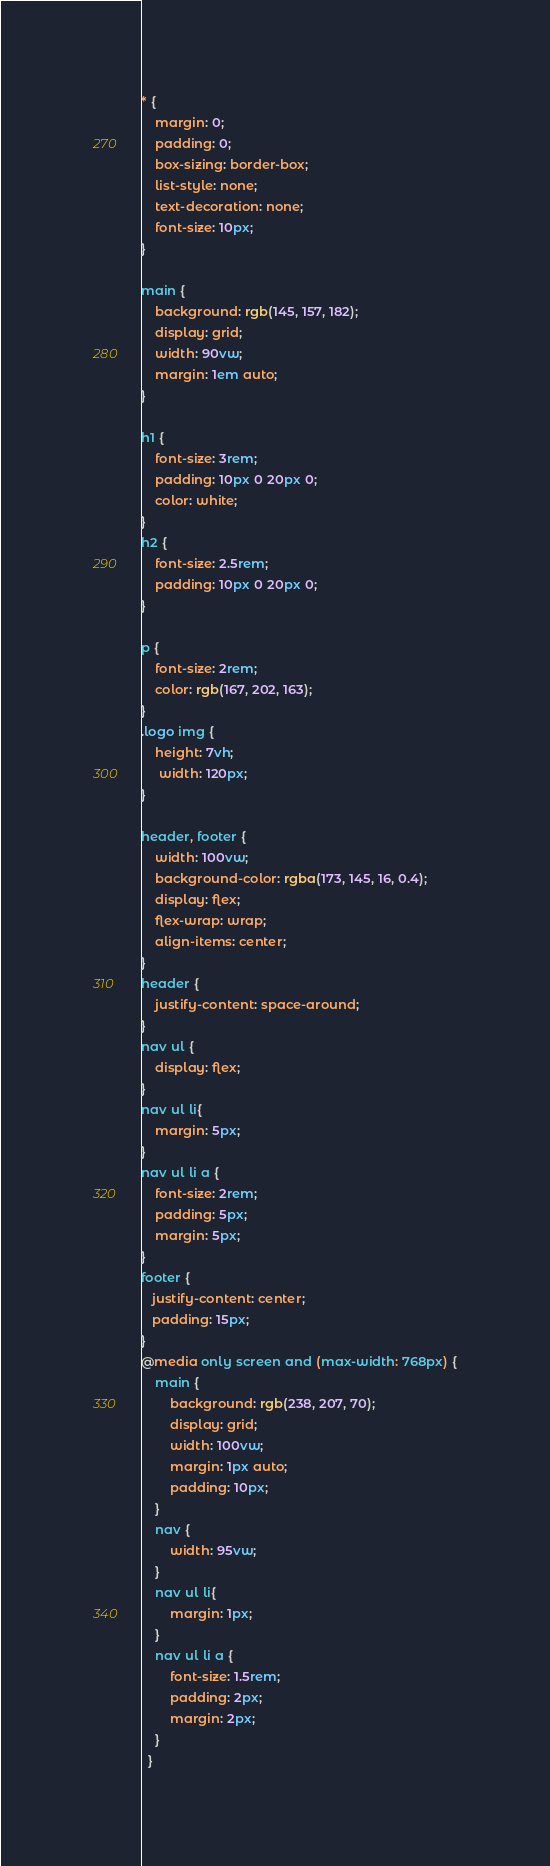Convert code to text. <code><loc_0><loc_0><loc_500><loc_500><_CSS_>* {    
    margin: 0;
    padding: 0;
    box-sizing: border-box;   
    list-style: none;
    text-decoration: none;
    font-size: 10px;
}

main {
    background: rgb(145, 157, 182);
    display: grid;
    width: 90vw;   
    margin: 1em auto;
}

h1 {
    font-size: 3rem;
    padding: 10px 0 20px 0;
    color: white;
}
h2 {
    font-size: 2.5rem;
    padding: 10px 0 20px 0;
}

p {
    font-size: 2rem;
    color: rgb(167, 202, 163);
}
.logo img {
    height: 7vh;
     width: 120px;
}

header, footer {
    width: 100vw;
    background-color: rgba(173, 145, 16, 0.4);
    display: flex; 
    flex-wrap: wrap;    
    align-items: center;   
}
header {
    justify-content: space-around;
}
nav ul {
    display: flex;    
}
nav ul li{    
    margin: 5px;
}
nav ul li a {   
    font-size: 2rem;
    padding: 5px;
    margin: 5px;
}
footer {
   justify-content: center;  
   padding: 15px;
}
@media only screen and (max-width: 768px) {
    main {
        background: rgb(238, 207, 70);
        display: grid;
        width: 100vw;   
        margin: 1px auto;
        padding: 10px;
    }
    nav {
        width: 95vw;
    }
    nav ul li{    
        margin: 1px;
    }
    nav ul li a {   
        font-size: 1.5rem;
        padding: 2px;
        margin: 2px;
    }
  }

</code> 